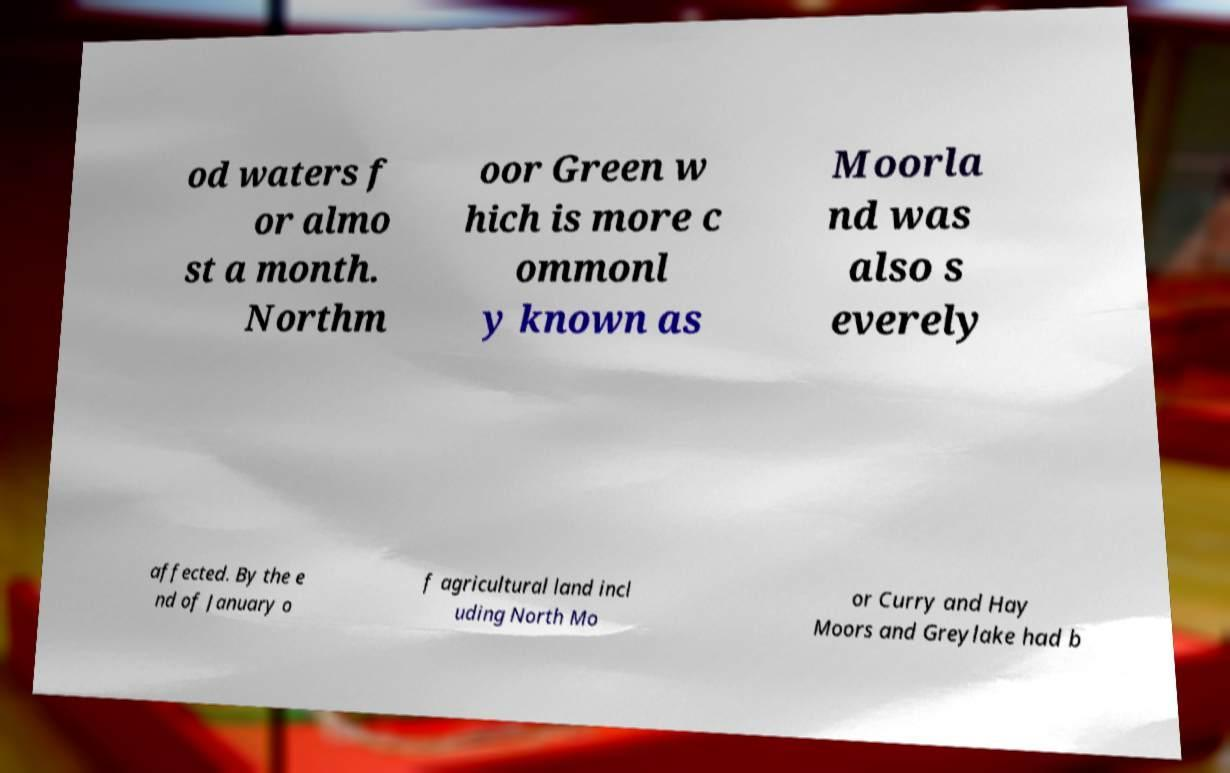There's text embedded in this image that I need extracted. Can you transcribe it verbatim? od waters f or almo st a month. Northm oor Green w hich is more c ommonl y known as Moorla nd was also s everely affected. By the e nd of January o f agricultural land incl uding North Mo or Curry and Hay Moors and Greylake had b 